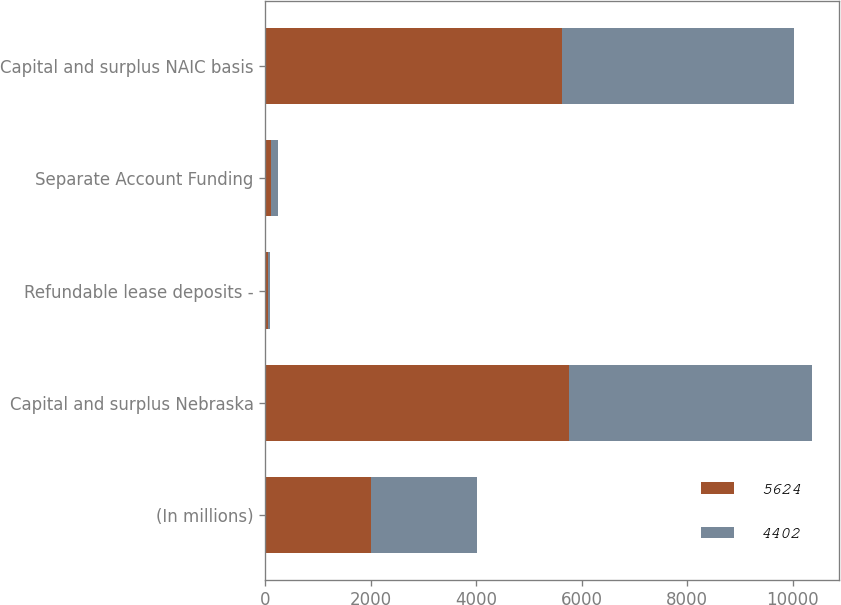<chart> <loc_0><loc_0><loc_500><loc_500><stacked_bar_chart><ecel><fcel>(In millions)<fcel>Capital and surplus Nebraska<fcel>Refundable lease deposits -<fcel>Separate Account Funding<fcel>Capital and surplus NAIC basis<nl><fcel>5624<fcel>2009<fcel>5768<fcel>46<fcel>98<fcel>5624<nl><fcel>4402<fcel>2008<fcel>4601<fcel>49<fcel>150<fcel>4402<nl></chart> 